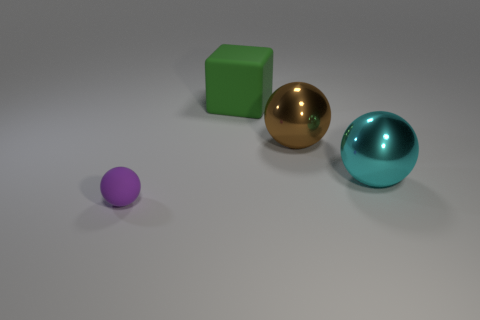What are the possible materials of the objects shown in the image? The purple object could be made of plastic or rubber. The green cube might also be plastic or some kind of painted wood. The golden sphere appears metallic, perhaps brass or gold-plated, and the cyan sphere looks like it could be glass or a polished semi-precious stone due to its translucency and gloss. 